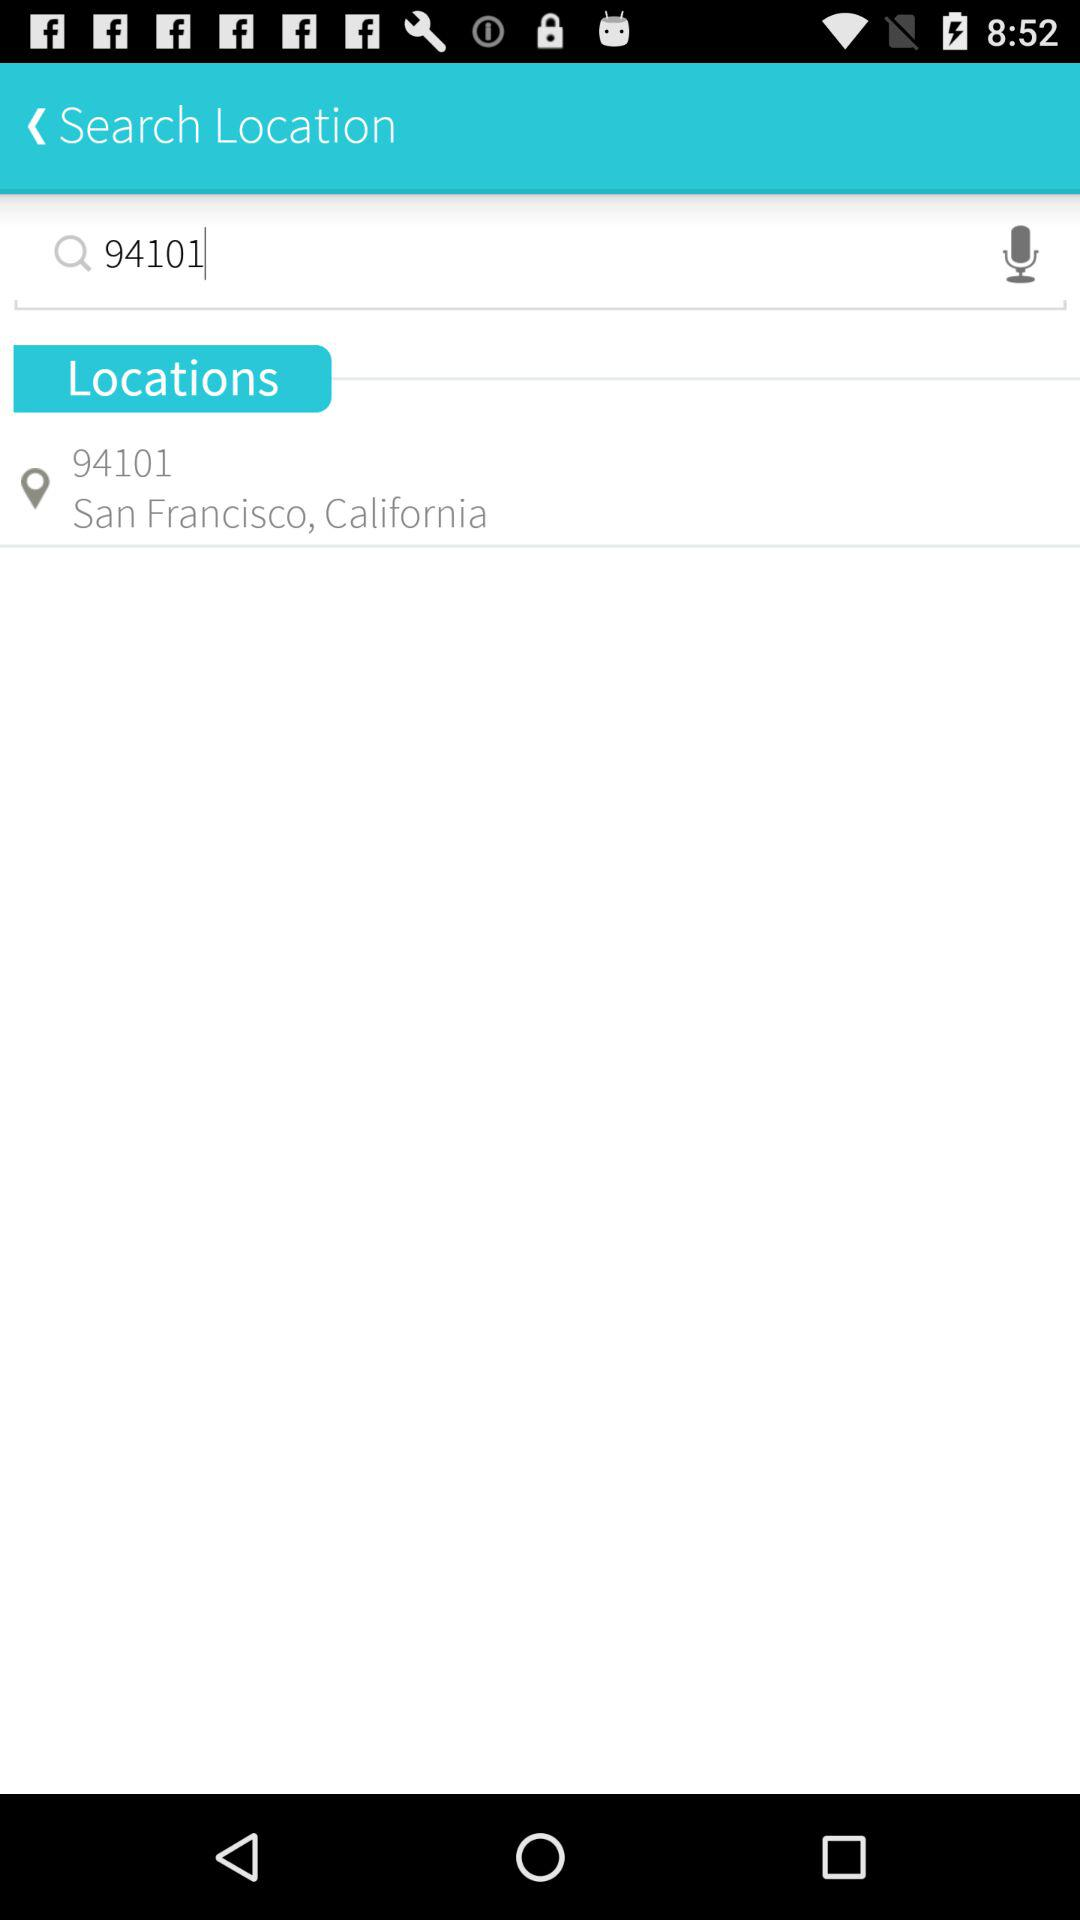What is the entered zip code? The entered zip code is 94101. 